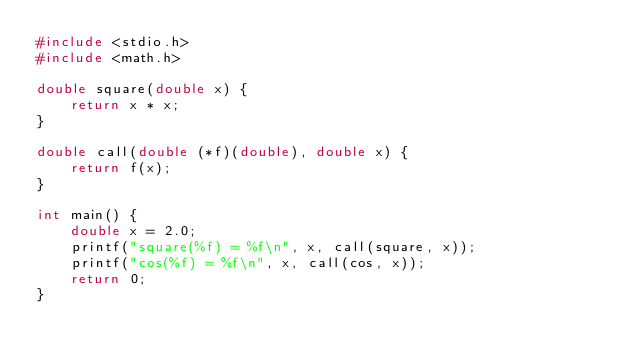<code> <loc_0><loc_0><loc_500><loc_500><_C_>#include <stdio.h>
#include <math.h>

double square(double x) {
    return x * x;
}

double call(double (*f)(double), double x) {
    return f(x);
}

int main() {
    double x = 2.0;
    printf("square(%f) = %f\n", x, call(square, x));
    printf("cos(%f) = %f\n", x, call(cos, x));
    return 0;
}
</code> 